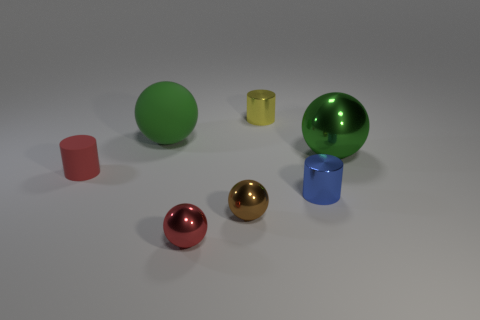What is the thing that is both in front of the red cylinder and right of the tiny yellow object made of?
Give a very brief answer. Metal. Are there any shiny cylinders that are behind the big sphere that is left of the tiny thing that is in front of the small brown shiny object?
Ensure brevity in your answer.  Yes. What size is the metal sphere that is the same color as the large matte sphere?
Ensure brevity in your answer.  Large. There is a matte sphere; are there any big rubber spheres behind it?
Offer a very short reply. No. How many other things are there of the same shape as the tiny yellow object?
Offer a very short reply. 2. There is a metal sphere that is the same size as the brown object; what is its color?
Provide a succinct answer. Red. Is the number of brown balls in front of the red matte cylinder less than the number of cylinders behind the tiny blue cylinder?
Offer a terse response. Yes. There is a tiny cylinder that is behind the big ball to the right of the tiny yellow cylinder; how many big objects are on the right side of it?
Keep it short and to the point. 1. The blue metal thing that is the same shape as the small red matte object is what size?
Make the answer very short. Small. Is there anything else that has the same size as the blue metallic thing?
Make the answer very short. Yes. 